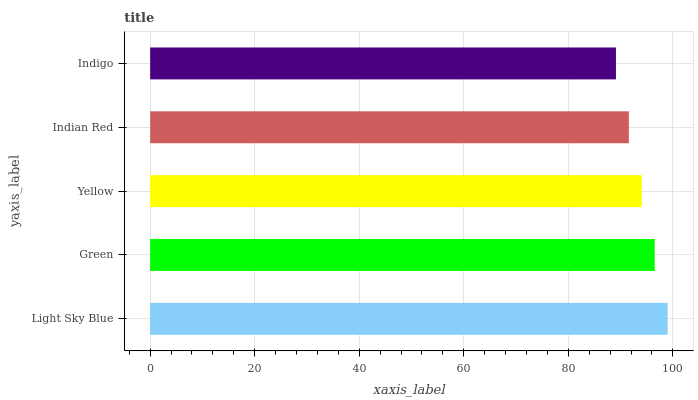Is Indigo the minimum?
Answer yes or no. Yes. Is Light Sky Blue the maximum?
Answer yes or no. Yes. Is Green the minimum?
Answer yes or no. No. Is Green the maximum?
Answer yes or no. No. Is Light Sky Blue greater than Green?
Answer yes or no. Yes. Is Green less than Light Sky Blue?
Answer yes or no. Yes. Is Green greater than Light Sky Blue?
Answer yes or no. No. Is Light Sky Blue less than Green?
Answer yes or no. No. Is Yellow the high median?
Answer yes or no. Yes. Is Yellow the low median?
Answer yes or no. Yes. Is Indian Red the high median?
Answer yes or no. No. Is Indigo the low median?
Answer yes or no. No. 